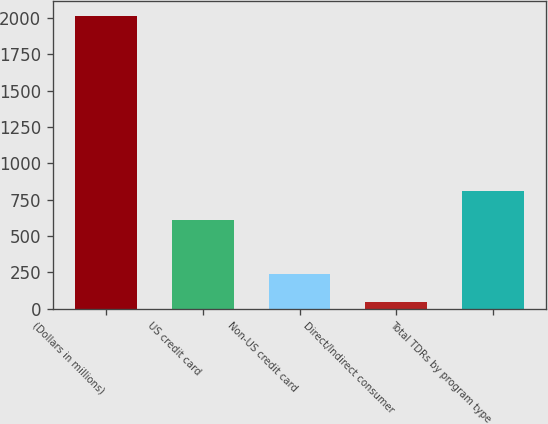Convert chart to OTSL. <chart><loc_0><loc_0><loc_500><loc_500><bar_chart><fcel>(Dollars in millions)<fcel>US credit card<fcel>Non-US credit card<fcel>Direct/Indirect consumer<fcel>Total TDRs by program type<nl><fcel>2015<fcel>611<fcel>239.3<fcel>42<fcel>808.3<nl></chart> 